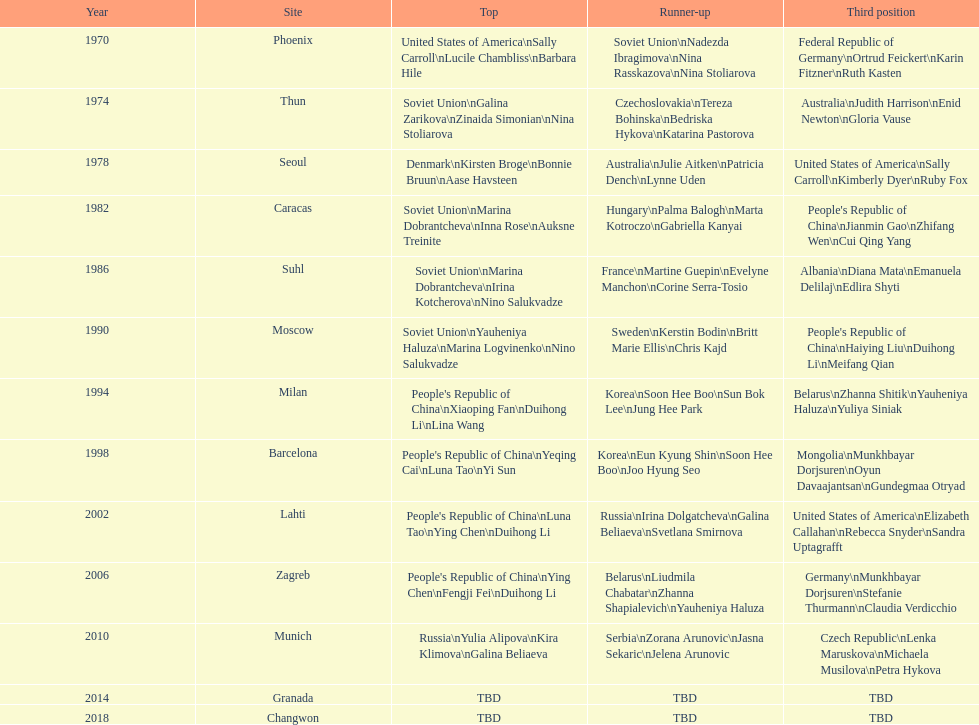Whose name is listed before bonnie bruun's in the gold column? Kirsten Broge. 